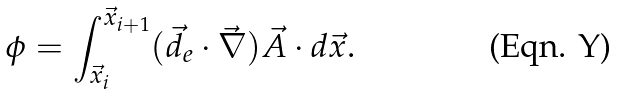<formula> <loc_0><loc_0><loc_500><loc_500>\phi = \int _ { \vec { x } _ { i } } ^ { \vec { x } _ { i + 1 } } ( \vec { d } _ { e } \cdot \vec { \nabla } ) \vec { A } \cdot d \vec { x } .</formula> 